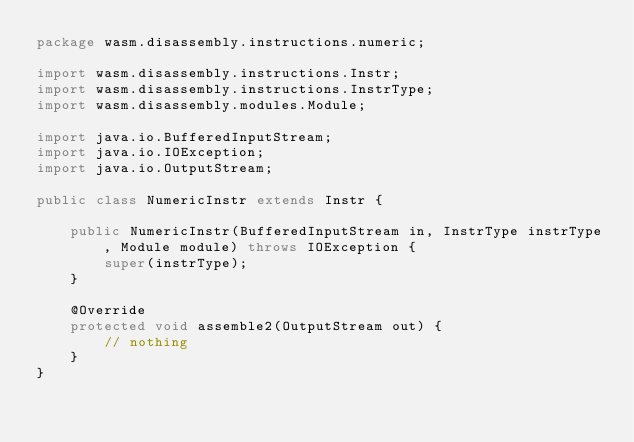Convert code to text. <code><loc_0><loc_0><loc_500><loc_500><_Java_>package wasm.disassembly.instructions.numeric;

import wasm.disassembly.instructions.Instr;
import wasm.disassembly.instructions.InstrType;
import wasm.disassembly.modules.Module;

import java.io.BufferedInputStream;
import java.io.IOException;
import java.io.OutputStream;

public class NumericInstr extends Instr {

    public NumericInstr(BufferedInputStream in, InstrType instrType, Module module) throws IOException {
        super(instrType);
    }

    @Override
    protected void assemble2(OutputStream out) {
        // nothing
    }
}
</code> 